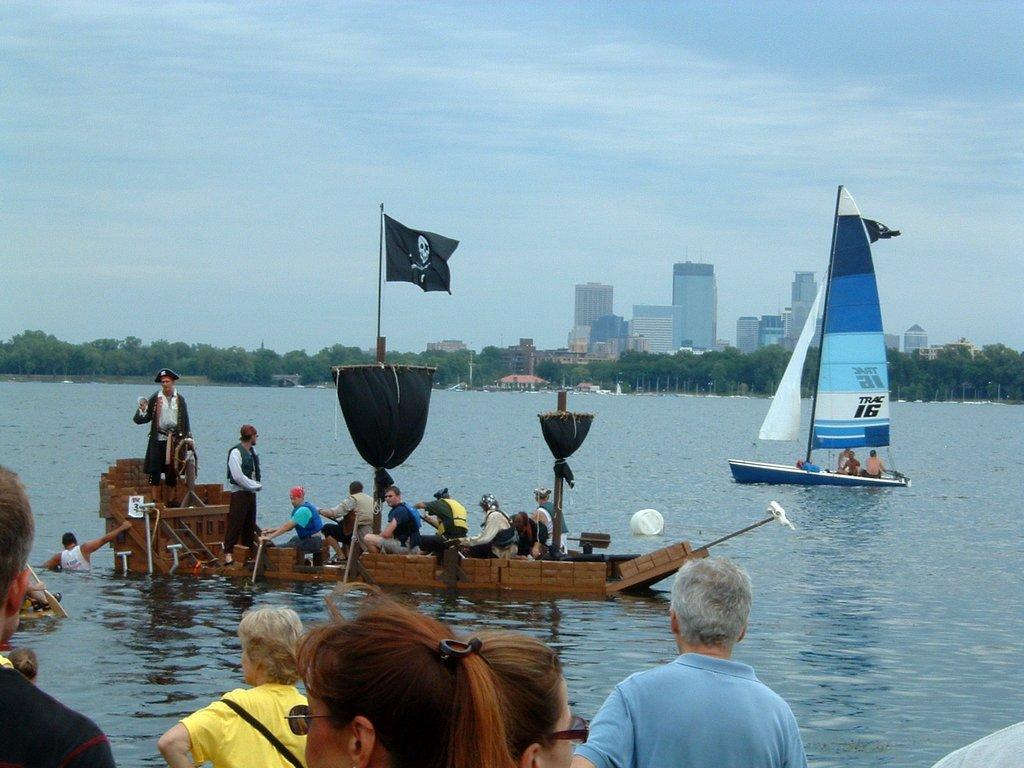In one or two sentences, can you explain what this image depicts? In this picture, we see many people sitting in the boat. The man in yellow T-shirt is sailing the boat in the water. On top of the boat, we see a black color flag. Beside that, we see a yacht. At the bottom of the picture, we see people standing. There are many trees and buildings in the background. At the top of the picture, we see the sky. 